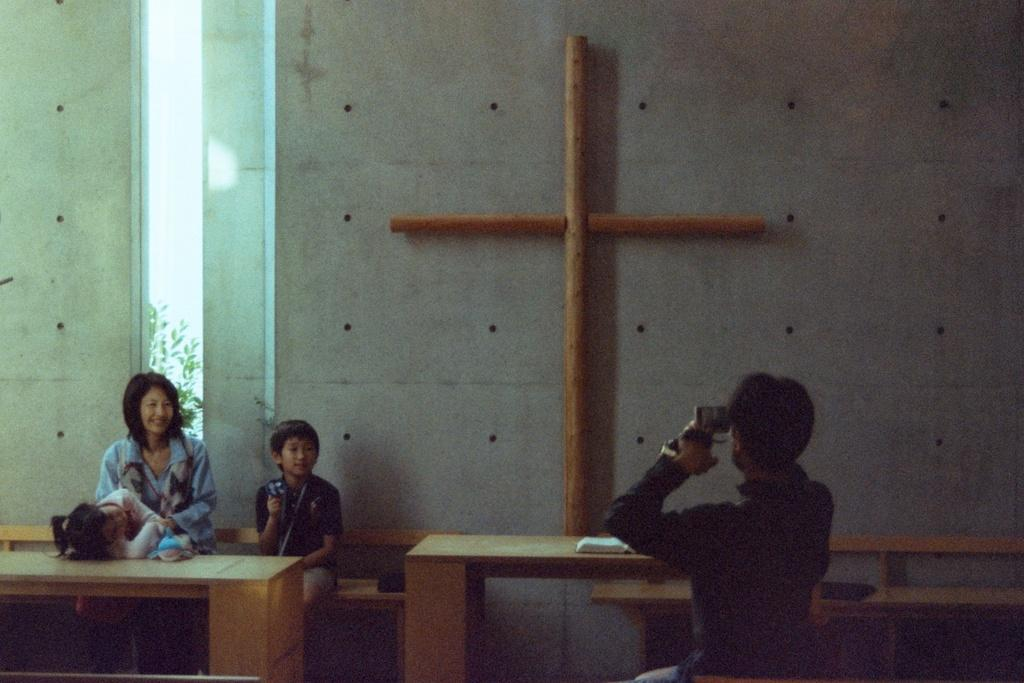How many people are seated in the image? There are two people seated on a bench in the image. What is one of the people doing with their hands? One person is seated and holding a camera in his hand. What is the person with the camera doing? The person with the camera is taking a picture. What type of ring is the person with the camera wearing on their finger? There is no mention of a ring in the image, so it cannot be determined if the person is wearing one. 